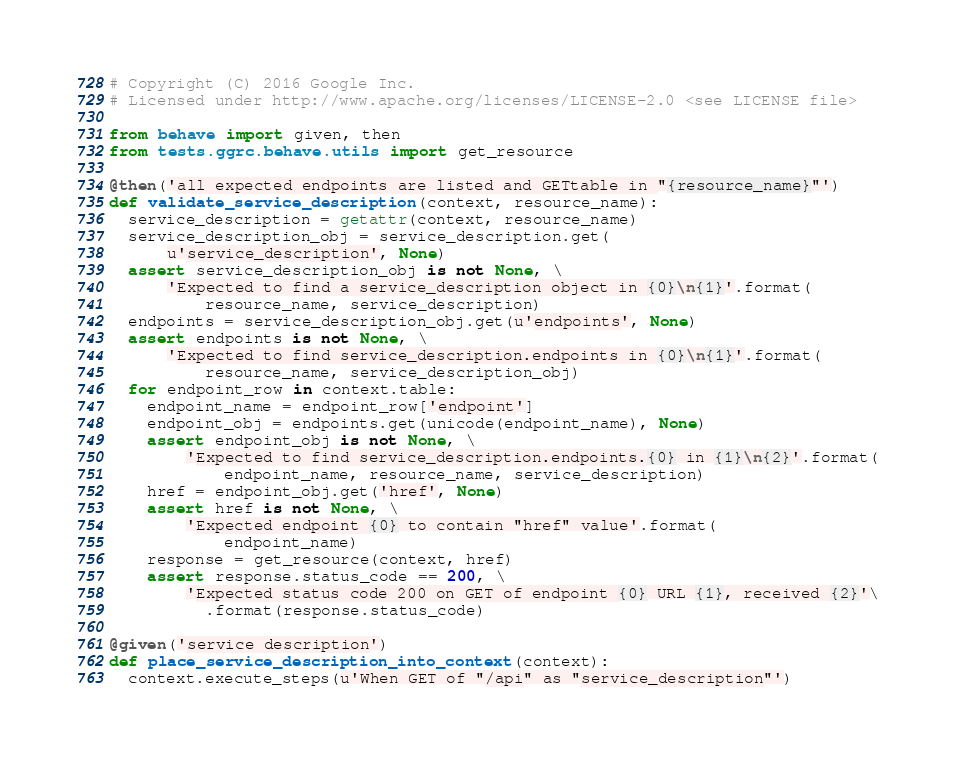<code> <loc_0><loc_0><loc_500><loc_500><_Python_># Copyright (C) 2016 Google Inc.
# Licensed under http://www.apache.org/licenses/LICENSE-2.0 <see LICENSE file>

from behave import given, then
from tests.ggrc.behave.utils import get_resource

@then('all expected endpoints are listed and GETtable in "{resource_name}"')
def validate_service_description(context, resource_name):
  service_description = getattr(context, resource_name)
  service_description_obj = service_description.get(
      u'service_description', None)
  assert service_description_obj is not None, \
      'Expected to find a service_description object in {0}\n{1}'.format(
          resource_name, service_description)
  endpoints = service_description_obj.get(u'endpoints', None)
  assert endpoints is not None, \
      'Expected to find service_description.endpoints in {0}\n{1}'.format(
          resource_name, service_description_obj)
  for endpoint_row in context.table:
    endpoint_name = endpoint_row['endpoint']
    endpoint_obj = endpoints.get(unicode(endpoint_name), None)
    assert endpoint_obj is not None, \
        'Expected to find service_description.endpoints.{0} in {1}\n{2}'.format(
            endpoint_name, resource_name, service_description)
    href = endpoint_obj.get('href', None)
    assert href is not None, \
        'Expected endpoint {0} to contain "href" value'.format(
            endpoint_name)
    response = get_resource(context, href)
    assert response.status_code == 200, \
        'Expected status code 200 on GET of endpoint {0} URL {1}, received {2}'\
          .format(response.status_code)

@given('service description')
def place_service_description_into_context(context):
  context.execute_steps(u'When GET of "/api" as "service_description"')
</code> 